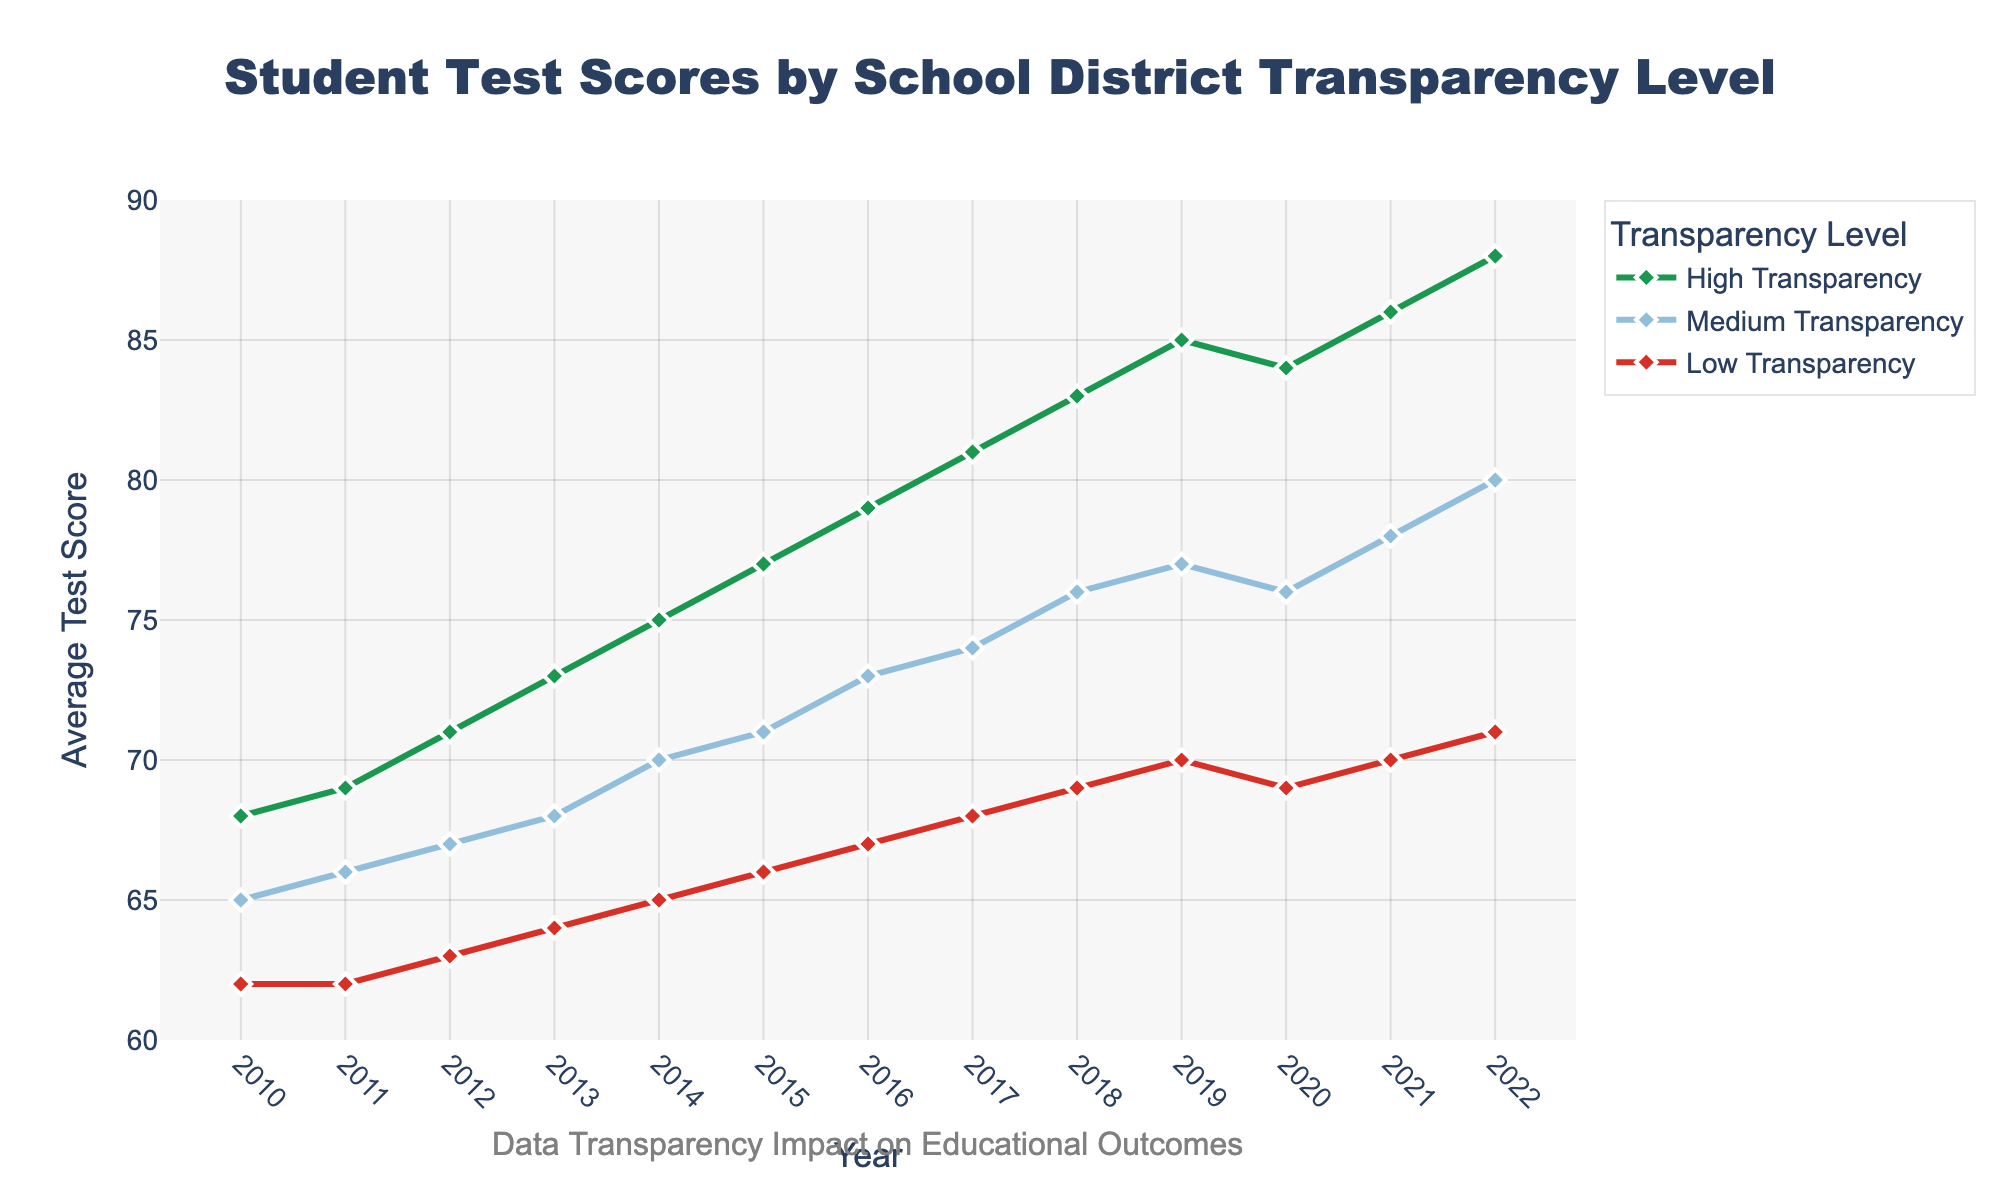What is the trend in the student test scores for high transparency school districts over the years? The line chart shows an upward trend in student test scores for high transparency school districts from 2010 to 2022. The scores increase steadily from 68 in 2010 to 88 in 2022.
Answer: Upward trend Which year had the highest student test score for medium transparency school districts? Referring to the line chart, the highest student test score for medium transparency school districts was in 2022, where the score was 80.
Answer: 2022 Compare the student test scores for low transparency school districts in 2010 and 2022. How much did the scores change? In 2010, the test score for low transparency school districts was 62. In 2022, it was 71. The change can be calculated as 71 - 62, which equals 9.
Answer: 9 What is the average student test score for high transparency school districts from 2010 to 2020? To find the average, sum up the scores for high transparency from 2010 to 2020 (68+69+71+73+75+77+79+81+83+85=741) and then divide by the number of years (11). So, 741 / 11 ≈ 67.36
Answer: 67.36 Which transparency level saw the most rapid improvement in student test scores over the observed period? Based on the slopes of the lines, high transparency school districts saw themost rapid improvement, where test scores increased by 20 points from 2010 to 2022. Medium transparency went up by 15 points and low transparency by 9 points.
Answer: High transparency How did student test scores for low transparency school districts perform from 2019 to 2020? According to the chart, student test scores for low transparency remained the same from 2019 to 2020, both at 69.
Answer: No change What is the difference in student test scores between high and medium transparency school districts in 2015? The test score for high transparency in 2015 was 77, while for medium transparency it was 71. The difference is calculated as 77 - 71, which equals 6.
Answer: 6 Identify the year when student test scores for high transparency school districts surpassed 80 for the first time. Looking at the high transparency score trend, it surpassed 80 for the first time in 2017 when it reached 81.
Answer: 2017 How do the test scores for medium transparency in 2018 compare to those for high transparency in 2015? The test score for medium transparency in 2018 was 76, while for high transparency in 2015 it was 77. Therefore, the medium transparency score in 2018 was 1 point less.
Answer: 1 point less Which transparency level has the most consistent trend in student test scores without any year-to-year drop from 2010 to 2022? Looking at the line trends, the high transparency school district scores show a consistent upward trend without any drops from 2010 to 2022.
Answer: High transparency 